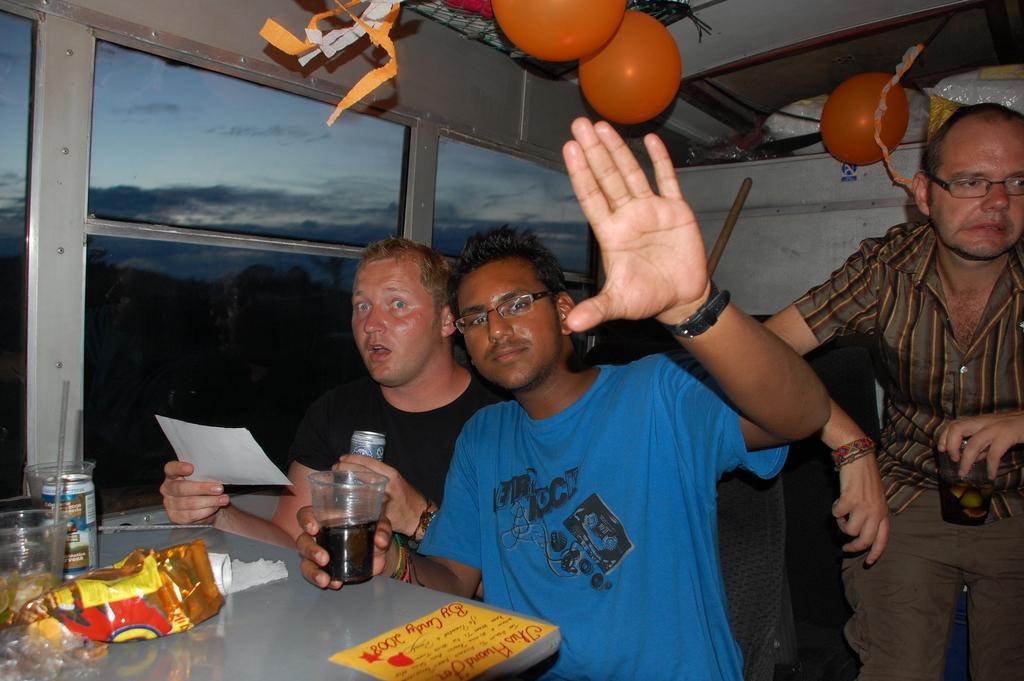In one or two sentences, can you explain what this image depicts? In the bottom left corner of the image we can see a table, on the table we can see some packets and glasses. In the middle of the image few people are sitting, standing and holding some glasses, tins and papers. Behind them we can see a window. Through the window we can see some trees and clouds in the sky. At the top of the image we can see ceiling, on the ceiling we can see some balloons. 